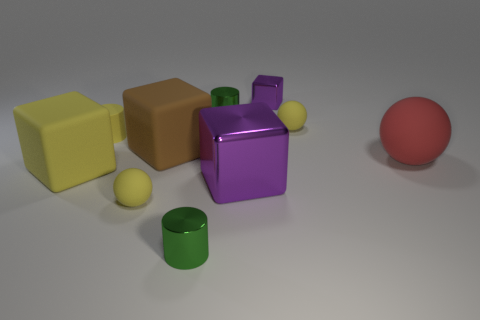Subtract all brown spheres. How many purple blocks are left? 2 Subtract all red spheres. How many spheres are left? 2 Subtract all yellow blocks. How many blocks are left? 3 Subtract 1 cylinders. How many cylinders are left? 2 Subtract all balls. How many objects are left? 7 Subtract all red cylinders. Subtract all red cubes. How many cylinders are left? 3 Add 1 yellow cylinders. How many yellow cylinders exist? 2 Subtract 2 yellow balls. How many objects are left? 8 Subtract all tiny metal things. Subtract all big red spheres. How many objects are left? 6 Add 7 red balls. How many red balls are left? 8 